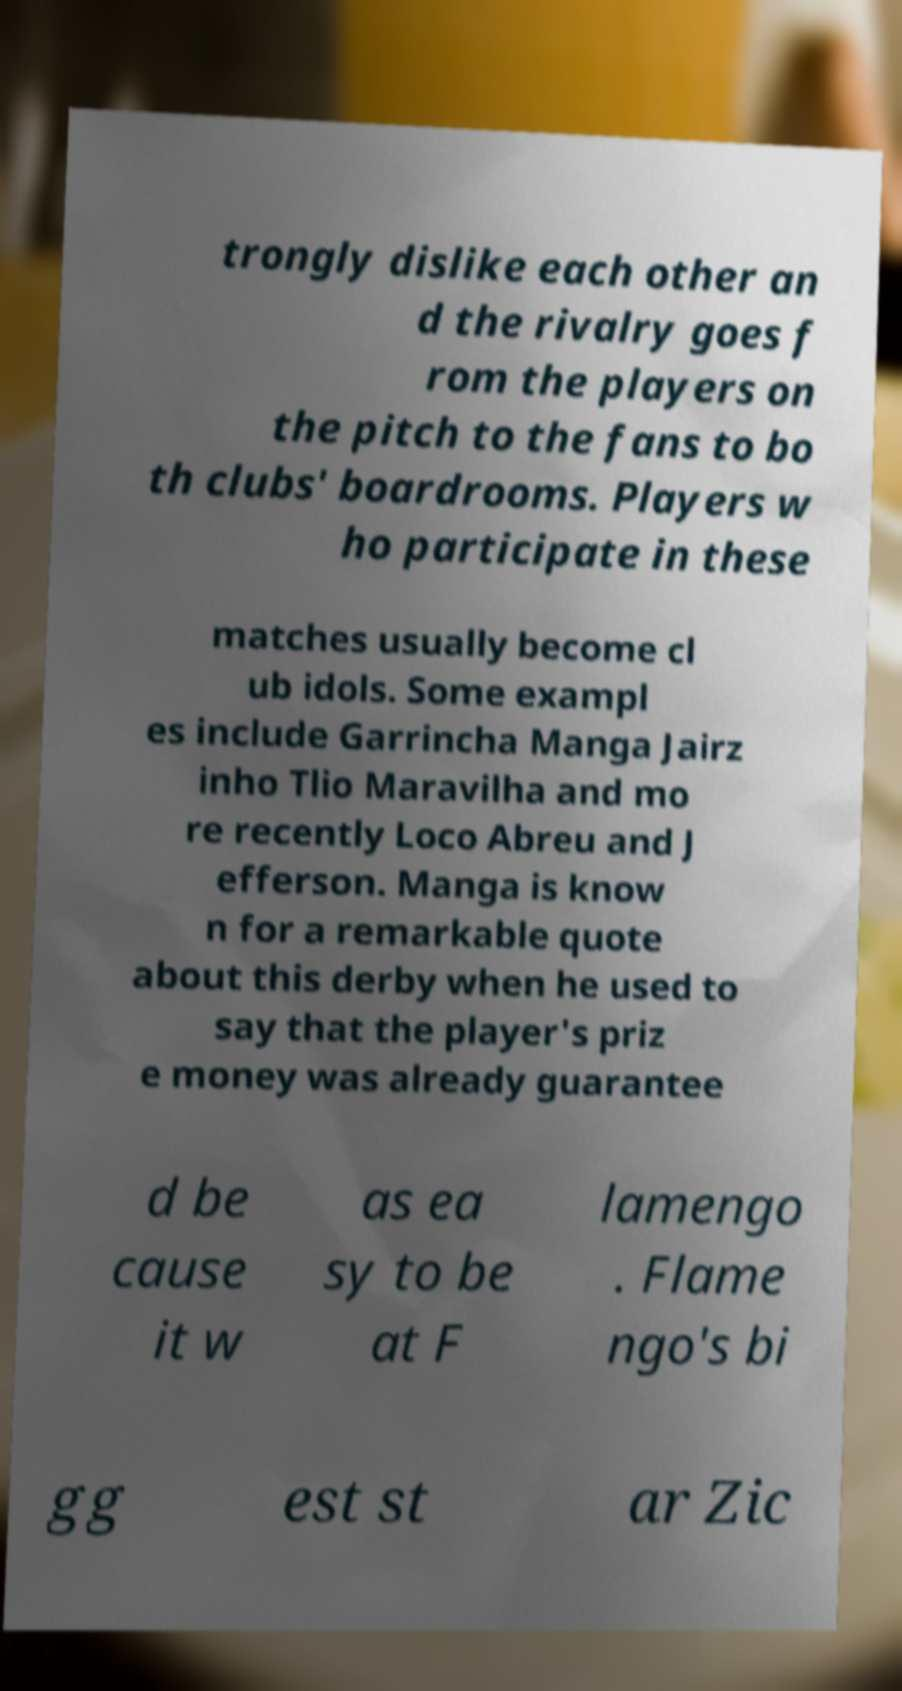Could you assist in decoding the text presented in this image and type it out clearly? trongly dislike each other an d the rivalry goes f rom the players on the pitch to the fans to bo th clubs' boardrooms. Players w ho participate in these matches usually become cl ub idols. Some exampl es include Garrincha Manga Jairz inho Tlio Maravilha and mo re recently Loco Abreu and J efferson. Manga is know n for a remarkable quote about this derby when he used to say that the player's priz e money was already guarantee d be cause it w as ea sy to be at F lamengo . Flame ngo's bi gg est st ar Zic 